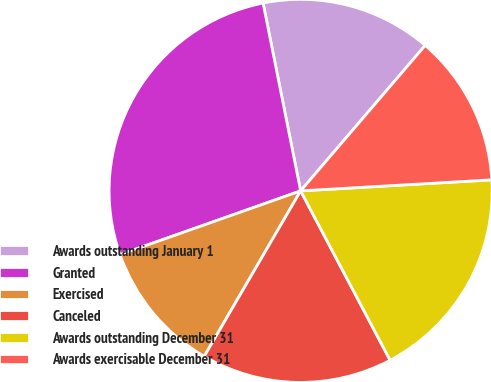Convert chart to OTSL. <chart><loc_0><loc_0><loc_500><loc_500><pie_chart><fcel>Awards outstanding January 1<fcel>Granted<fcel>Exercised<fcel>Canceled<fcel>Awards outstanding December 31<fcel>Awards exercisable December 31<nl><fcel>14.41%<fcel>27.26%<fcel>11.2%<fcel>16.13%<fcel>18.18%<fcel>12.81%<nl></chart> 